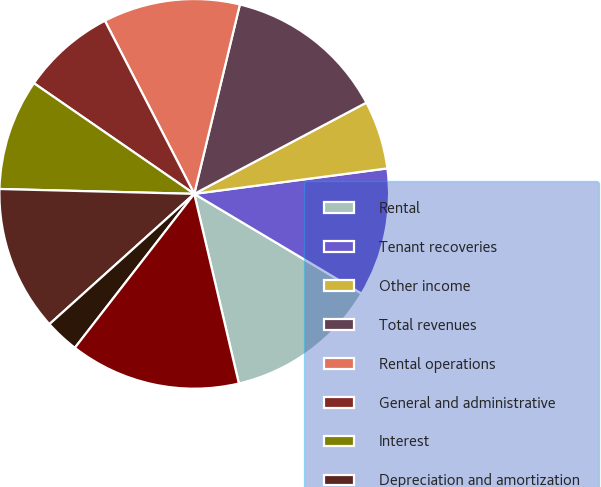Convert chart. <chart><loc_0><loc_0><loc_500><loc_500><pie_chart><fcel>Rental<fcel>Tenant recoveries<fcel>Other income<fcel>Total revenues<fcel>Rental operations<fcel>General and administrative<fcel>Interest<fcel>Depreciation and amortization<fcel>Loss on early extinguishment<fcel>Total expenses<nl><fcel>12.77%<fcel>10.64%<fcel>5.67%<fcel>13.48%<fcel>11.35%<fcel>7.8%<fcel>9.22%<fcel>12.06%<fcel>2.84%<fcel>14.18%<nl></chart> 